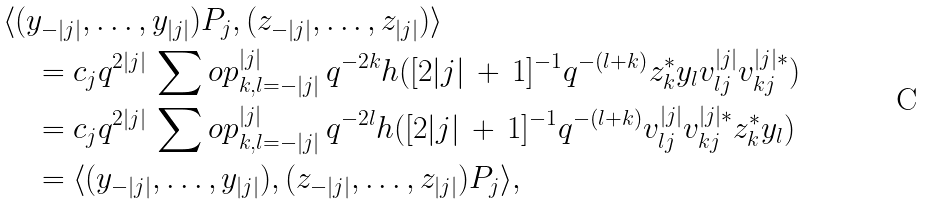Convert formula to latex. <formula><loc_0><loc_0><loc_500><loc_500>& \langle ( y _ { - | j | } , \dots , y _ { | j | } ) P _ { j } , ( z _ { - | j | } , \dots , z _ { | j | } ) \rangle \\ & \quad = c _ { j } q ^ { 2 | j | } \, \sum o p _ { k , l = - | j | } ^ { | j | } \, q ^ { - 2 k } h ( [ 2 | j | \, + \, 1 ] ^ { - 1 } q ^ { - ( l + k ) } z _ { k } ^ { \ast } y _ { l } v ^ { | j | } _ { l j } v ^ { | j | \ast } _ { k j } ) \\ & \quad = c _ { j } q ^ { 2 | j | } \, \sum o p _ { k , l = - | j | } ^ { | j | } \, q ^ { - 2 l } h ( [ 2 | j | \, + \, 1 ] ^ { - 1 } q ^ { - ( l + k ) } v ^ { | j | } _ { l j } v ^ { | j | \ast } _ { k j } z _ { k } ^ { \ast } y _ { l } ) \\ & \quad = \langle ( y _ { - | j | } , \dots , y _ { | j | } ) , ( z _ { - | j | } , \dots , z _ { | j | } ) P _ { j } \rangle ,</formula> 